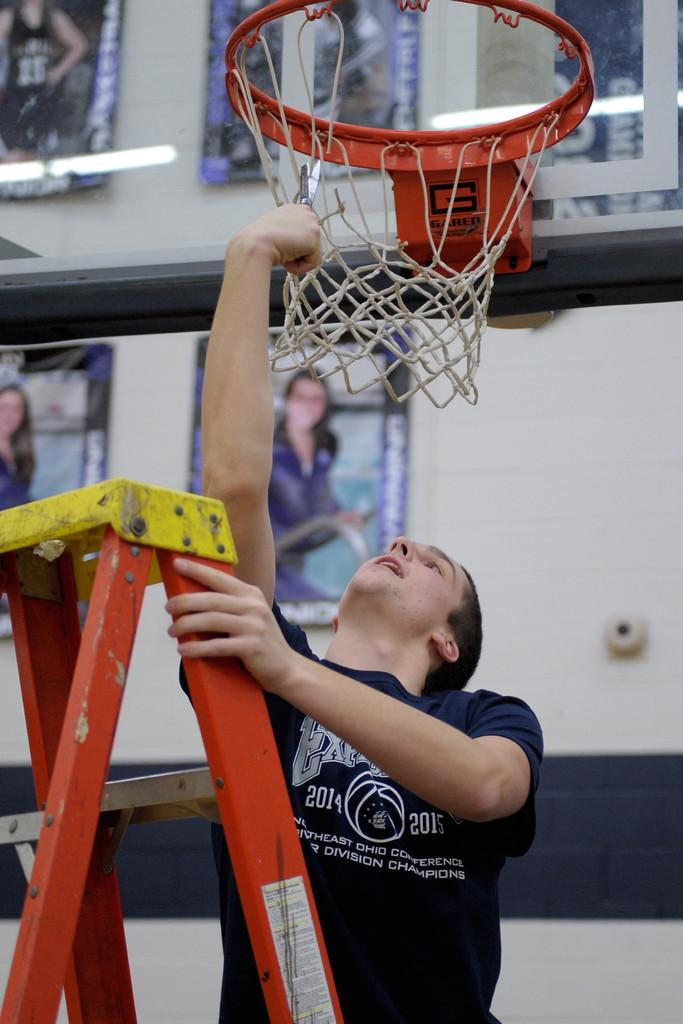<image>
Summarize the visual content of the image. a guy fixing a basketball net that has the letter G on the neck of it 